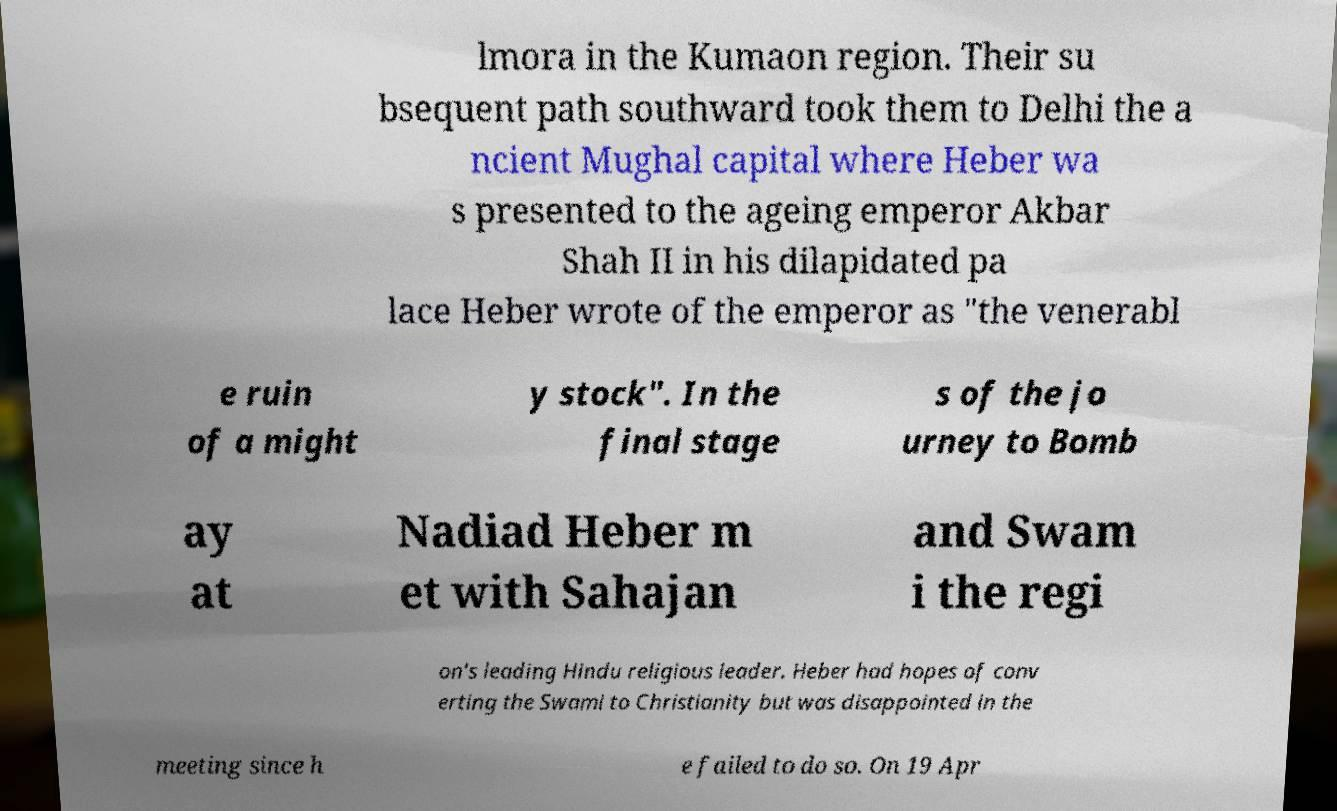I need the written content from this picture converted into text. Can you do that? lmora in the Kumaon region. Their su bsequent path southward took them to Delhi the a ncient Mughal capital where Heber wa s presented to the ageing emperor Akbar Shah II in his dilapidated pa lace Heber wrote of the emperor as "the venerabl e ruin of a might y stock". In the final stage s of the jo urney to Bomb ay at Nadiad Heber m et with Sahajan and Swam i the regi on's leading Hindu religious leader. Heber had hopes of conv erting the Swami to Christianity but was disappointed in the meeting since h e failed to do so. On 19 Apr 